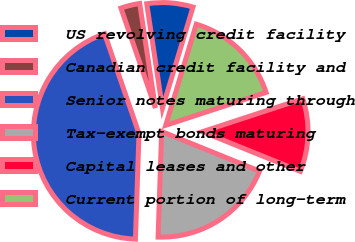<chart> <loc_0><loc_0><loc_500><loc_500><pie_chart><fcel>US revolving credit facility<fcel>Canadian credit facility and<fcel>Senior notes maturing through<fcel>Tax-exempt bonds maturing<fcel>Capital leases and other<fcel>Current portion of long-term<nl><fcel>7.04%<fcel>2.91%<fcel>44.18%<fcel>19.42%<fcel>11.16%<fcel>15.29%<nl></chart> 